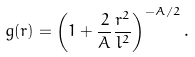<formula> <loc_0><loc_0><loc_500><loc_500>g ( r ) = \left ( 1 + \frac { 2 } { A } \frac { r ^ { 2 } } { l ^ { 2 } } \right ) ^ { - A / 2 } .</formula> 